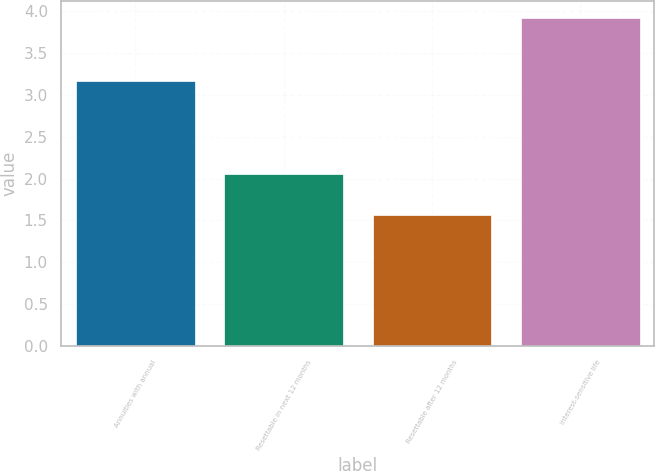Convert chart to OTSL. <chart><loc_0><loc_0><loc_500><loc_500><bar_chart><fcel>Annuities with annual<fcel>Resettable in next 12 months<fcel>Resettable after 12 months<fcel>Interest-sensitive life<nl><fcel>3.17<fcel>2.05<fcel>1.56<fcel>3.92<nl></chart> 